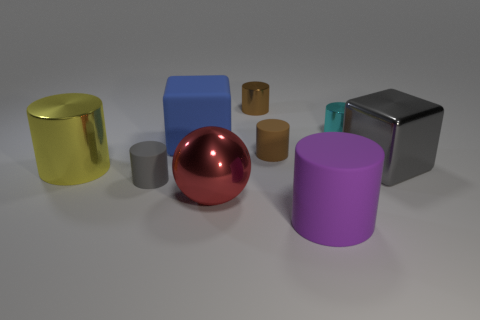Subtract all cyan cylinders. How many cylinders are left? 5 Subtract all cyan metal cylinders. How many cylinders are left? 5 Subtract all green cylinders. Subtract all gray blocks. How many cylinders are left? 6 Add 1 cylinders. How many objects exist? 10 Subtract all cubes. How many objects are left? 7 Add 8 tiny gray cylinders. How many tiny gray cylinders are left? 9 Add 2 big red objects. How many big red objects exist? 3 Subtract 0 green spheres. How many objects are left? 9 Subtract all purple rubber cylinders. Subtract all brown matte cubes. How many objects are left? 8 